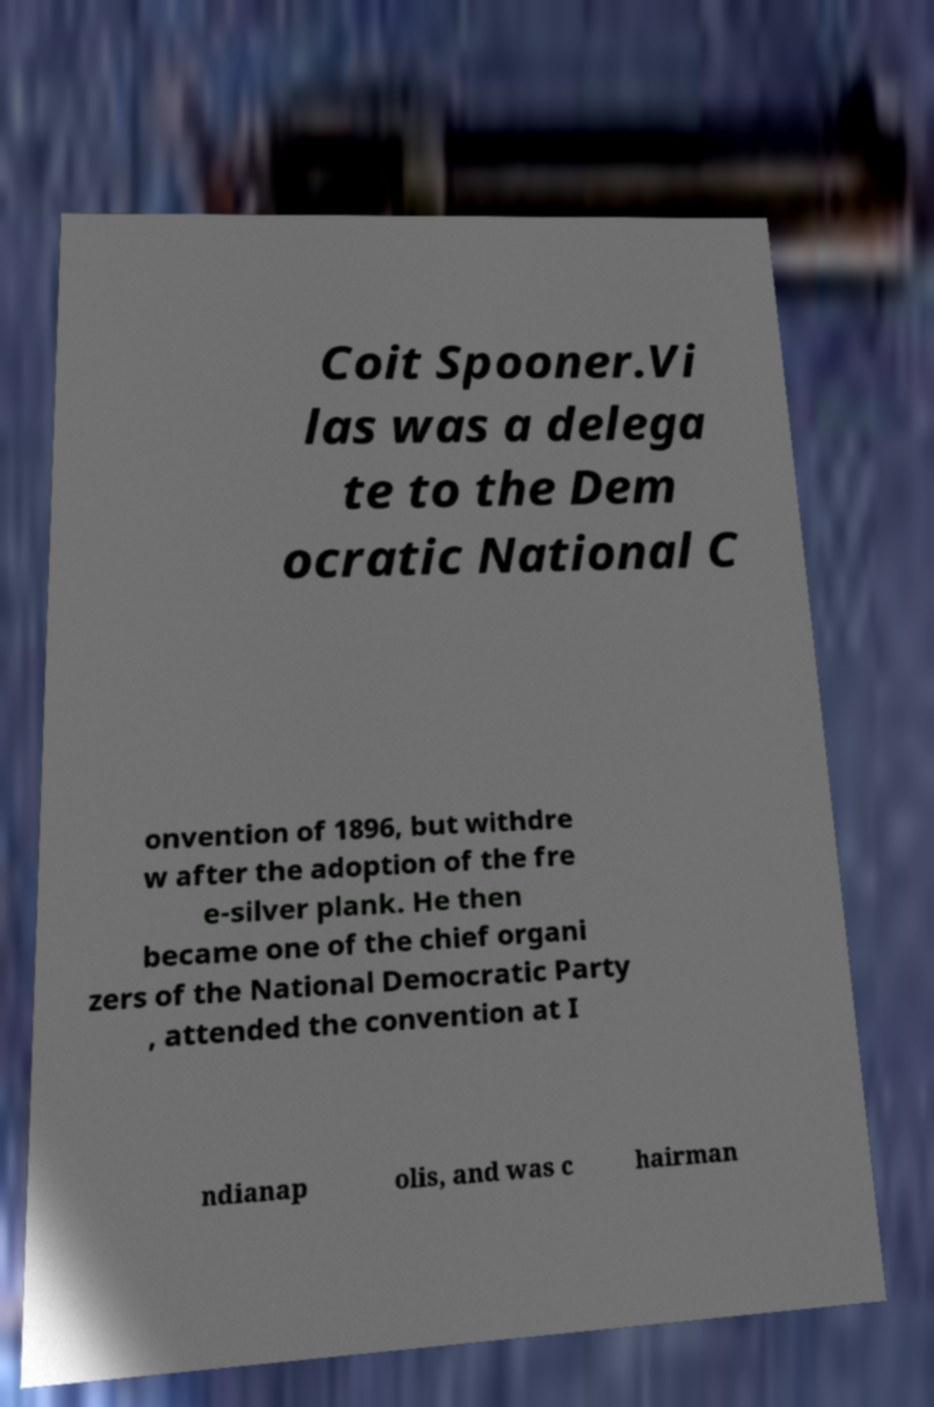Could you extract and type out the text from this image? Coit Spooner.Vi las was a delega te to the Dem ocratic National C onvention of 1896, but withdre w after the adoption of the fre e-silver plank. He then became one of the chief organi zers of the National Democratic Party , attended the convention at I ndianap olis, and was c hairman 